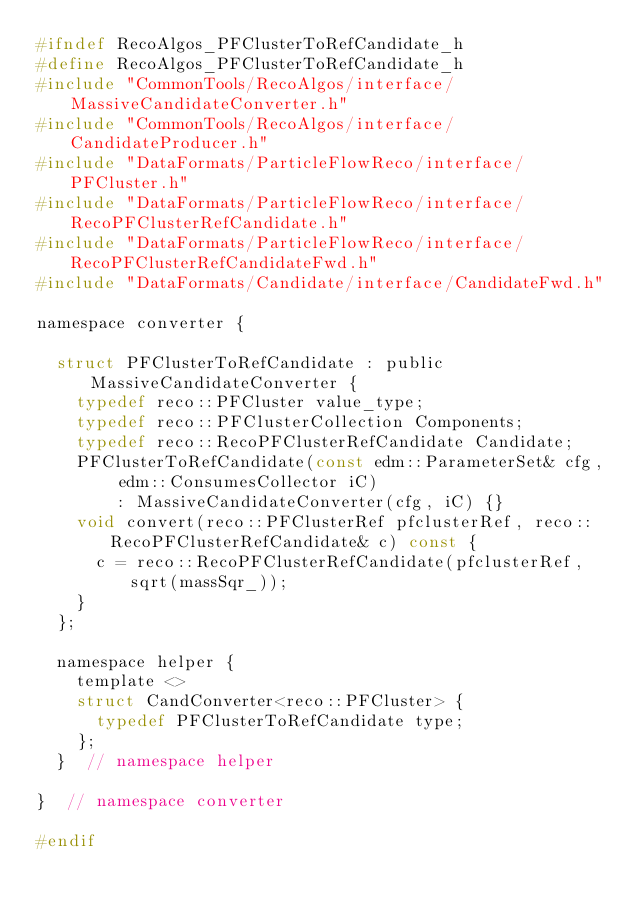Convert code to text. <code><loc_0><loc_0><loc_500><loc_500><_C_>#ifndef RecoAlgos_PFClusterToRefCandidate_h
#define RecoAlgos_PFClusterToRefCandidate_h
#include "CommonTools/RecoAlgos/interface/MassiveCandidateConverter.h"
#include "CommonTools/RecoAlgos/interface/CandidateProducer.h"
#include "DataFormats/ParticleFlowReco/interface/PFCluster.h"
#include "DataFormats/ParticleFlowReco/interface/RecoPFClusterRefCandidate.h"
#include "DataFormats/ParticleFlowReco/interface/RecoPFClusterRefCandidateFwd.h"
#include "DataFormats/Candidate/interface/CandidateFwd.h"

namespace converter {

  struct PFClusterToRefCandidate : public MassiveCandidateConverter {
    typedef reco::PFCluster value_type;
    typedef reco::PFClusterCollection Components;
    typedef reco::RecoPFClusterRefCandidate Candidate;
    PFClusterToRefCandidate(const edm::ParameterSet& cfg, edm::ConsumesCollector iC)
        : MassiveCandidateConverter(cfg, iC) {}
    void convert(reco::PFClusterRef pfclusterRef, reco::RecoPFClusterRefCandidate& c) const {
      c = reco::RecoPFClusterRefCandidate(pfclusterRef, sqrt(massSqr_));
    }
  };

  namespace helper {
    template <>
    struct CandConverter<reco::PFCluster> {
      typedef PFClusterToRefCandidate type;
    };
  }  // namespace helper

}  // namespace converter

#endif
</code> 